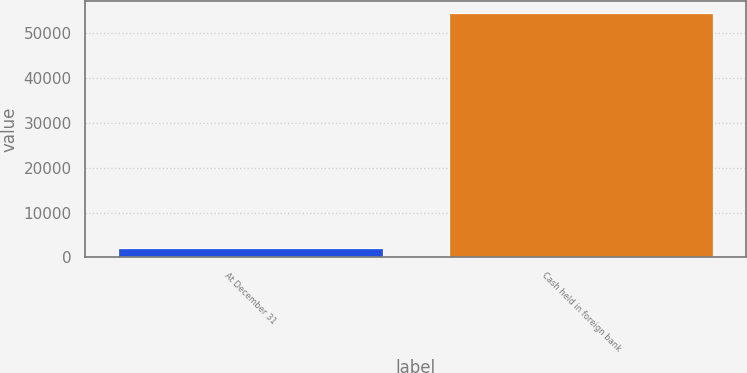Convert chart. <chart><loc_0><loc_0><loc_500><loc_500><bar_chart><fcel>At December 31<fcel>Cash held in foreign bank<nl><fcel>2016<fcel>54424<nl></chart> 